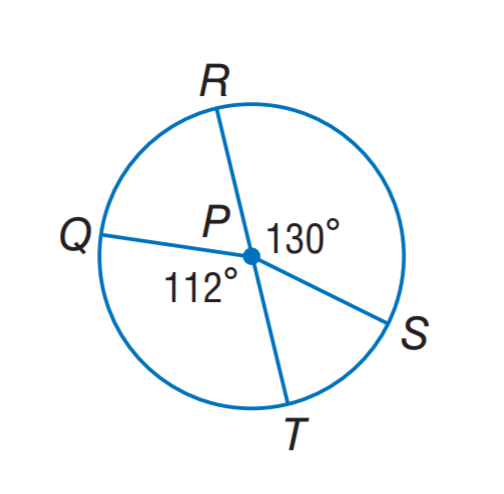Answer the mathemtical geometry problem and directly provide the correct option letter.
Question: In \odot P, the diameter is 9, find the length of \widehat Q T. Round to the nearest hundredth.
Choices: A: 8.80 B: 10.21 C: 17.60 D: 20.42 A 